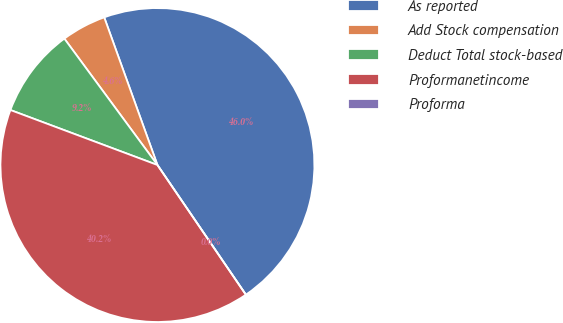Convert chart. <chart><loc_0><loc_0><loc_500><loc_500><pie_chart><fcel>As reported<fcel>Add Stock compensation<fcel>Deduct Total stock-based<fcel>Proformanetincome<fcel>Proforma<nl><fcel>45.98%<fcel>4.6%<fcel>9.2%<fcel>40.22%<fcel>0.0%<nl></chart> 